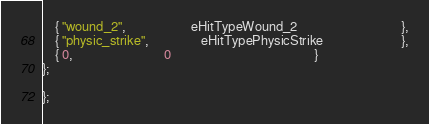<code> <loc_0><loc_0><loc_500><loc_500><_C++_>	{ "wound_2",					eHitTypeWound_2								},
	{ "physic_strike",				eHitTypePhysicStrike						},
	{ 0,							0											}
};

};</code> 